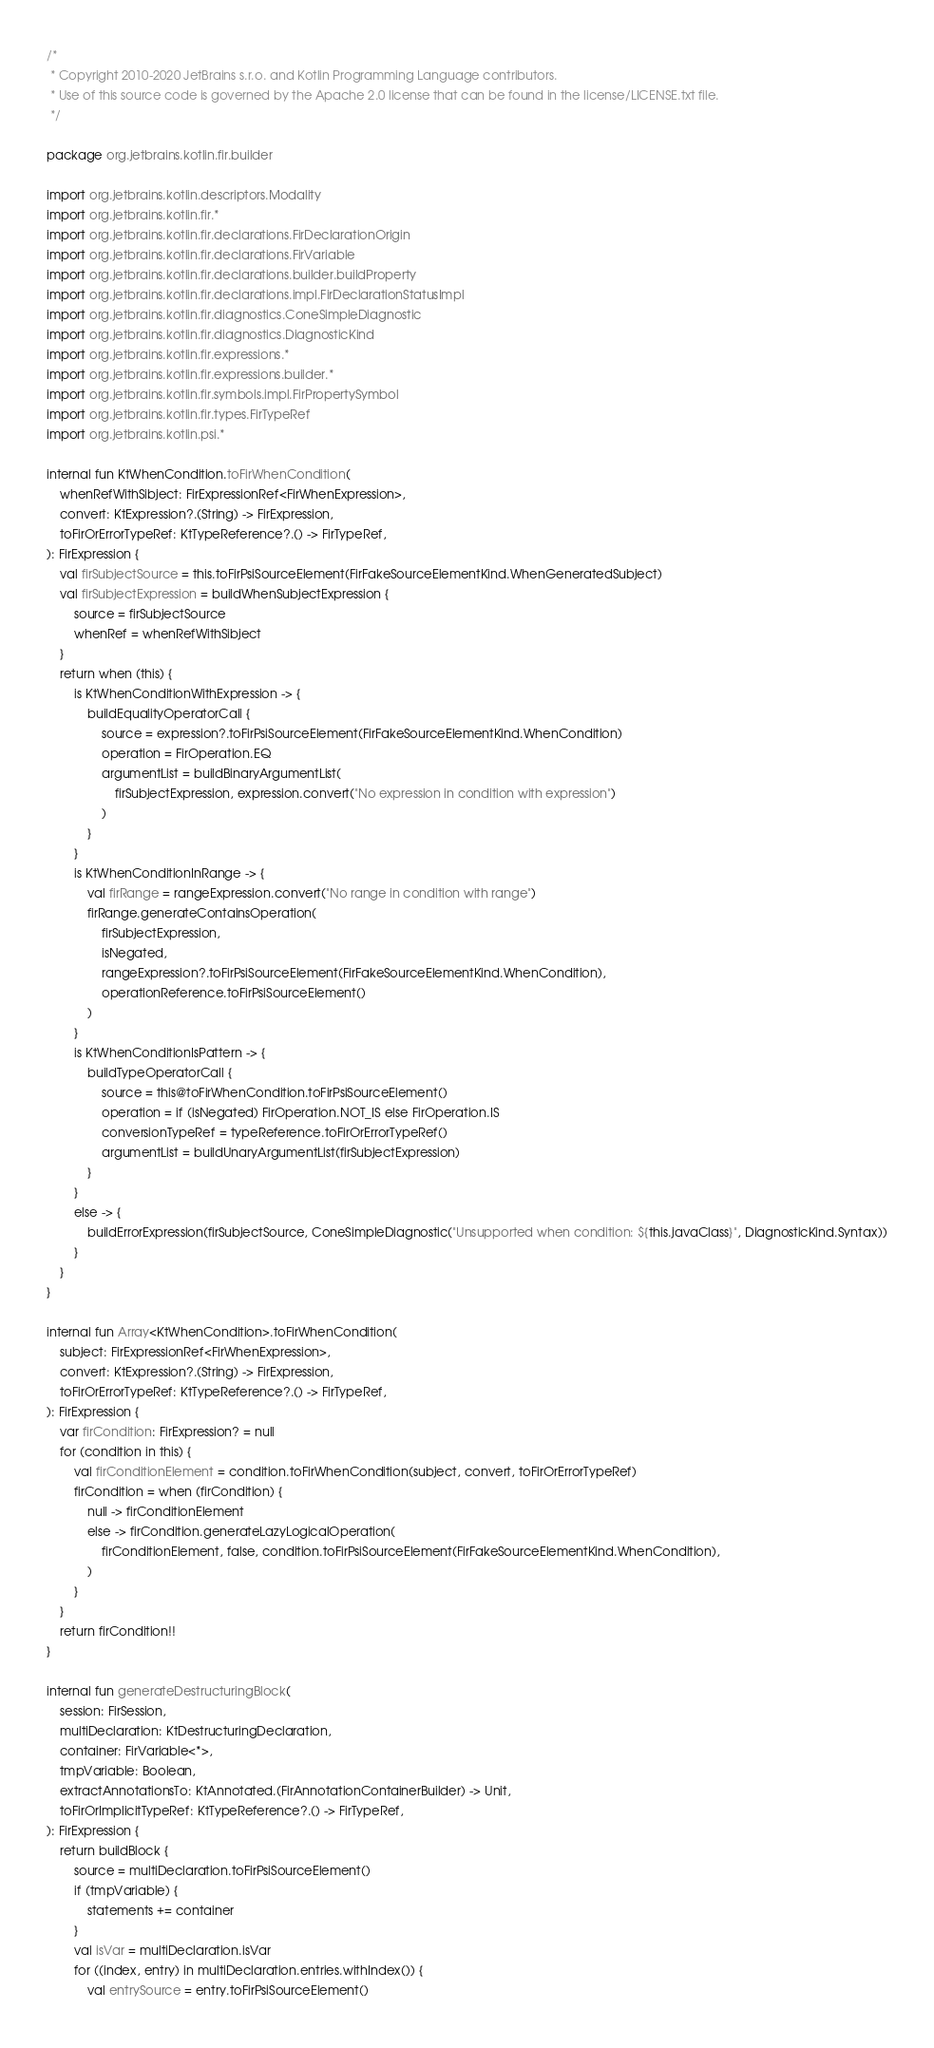Convert code to text. <code><loc_0><loc_0><loc_500><loc_500><_Kotlin_>/*
 * Copyright 2010-2020 JetBrains s.r.o. and Kotlin Programming Language contributors.
 * Use of this source code is governed by the Apache 2.0 license that can be found in the license/LICENSE.txt file.
 */

package org.jetbrains.kotlin.fir.builder

import org.jetbrains.kotlin.descriptors.Modality
import org.jetbrains.kotlin.fir.*
import org.jetbrains.kotlin.fir.declarations.FirDeclarationOrigin
import org.jetbrains.kotlin.fir.declarations.FirVariable
import org.jetbrains.kotlin.fir.declarations.builder.buildProperty
import org.jetbrains.kotlin.fir.declarations.impl.FirDeclarationStatusImpl
import org.jetbrains.kotlin.fir.diagnostics.ConeSimpleDiagnostic
import org.jetbrains.kotlin.fir.diagnostics.DiagnosticKind
import org.jetbrains.kotlin.fir.expressions.*
import org.jetbrains.kotlin.fir.expressions.builder.*
import org.jetbrains.kotlin.fir.symbols.impl.FirPropertySymbol
import org.jetbrains.kotlin.fir.types.FirTypeRef
import org.jetbrains.kotlin.psi.*

internal fun KtWhenCondition.toFirWhenCondition(
    whenRefWithSibject: FirExpressionRef<FirWhenExpression>,
    convert: KtExpression?.(String) -> FirExpression,
    toFirOrErrorTypeRef: KtTypeReference?.() -> FirTypeRef,
): FirExpression {
    val firSubjectSource = this.toFirPsiSourceElement(FirFakeSourceElementKind.WhenGeneratedSubject)
    val firSubjectExpression = buildWhenSubjectExpression {
        source = firSubjectSource
        whenRef = whenRefWithSibject
    }
    return when (this) {
        is KtWhenConditionWithExpression -> {
            buildEqualityOperatorCall {
                source = expression?.toFirPsiSourceElement(FirFakeSourceElementKind.WhenCondition)
                operation = FirOperation.EQ
                argumentList = buildBinaryArgumentList(
                    firSubjectExpression, expression.convert("No expression in condition with expression")
                )
            }
        }
        is KtWhenConditionInRange -> {
            val firRange = rangeExpression.convert("No range in condition with range")
            firRange.generateContainsOperation(
                firSubjectExpression,
                isNegated,
                rangeExpression?.toFirPsiSourceElement(FirFakeSourceElementKind.WhenCondition),
                operationReference.toFirPsiSourceElement()
            )
        }
        is KtWhenConditionIsPattern -> {
            buildTypeOperatorCall {
                source = this@toFirWhenCondition.toFirPsiSourceElement()
                operation = if (isNegated) FirOperation.NOT_IS else FirOperation.IS
                conversionTypeRef = typeReference.toFirOrErrorTypeRef()
                argumentList = buildUnaryArgumentList(firSubjectExpression)
            }
        }
        else -> {
            buildErrorExpression(firSubjectSource, ConeSimpleDiagnostic("Unsupported when condition: ${this.javaClass}", DiagnosticKind.Syntax))
        }
    }
}

internal fun Array<KtWhenCondition>.toFirWhenCondition(
    subject: FirExpressionRef<FirWhenExpression>,
    convert: KtExpression?.(String) -> FirExpression,
    toFirOrErrorTypeRef: KtTypeReference?.() -> FirTypeRef,
): FirExpression {
    var firCondition: FirExpression? = null
    for (condition in this) {
        val firConditionElement = condition.toFirWhenCondition(subject, convert, toFirOrErrorTypeRef)
        firCondition = when (firCondition) {
            null -> firConditionElement
            else -> firCondition.generateLazyLogicalOperation(
                firConditionElement, false, condition.toFirPsiSourceElement(FirFakeSourceElementKind.WhenCondition),
            )
        }
    }
    return firCondition!!
}

internal fun generateDestructuringBlock(
    session: FirSession,
    multiDeclaration: KtDestructuringDeclaration,
    container: FirVariable<*>,
    tmpVariable: Boolean,
    extractAnnotationsTo: KtAnnotated.(FirAnnotationContainerBuilder) -> Unit,
    toFirOrImplicitTypeRef: KtTypeReference?.() -> FirTypeRef,
): FirExpression {
    return buildBlock {
        source = multiDeclaration.toFirPsiSourceElement()
        if (tmpVariable) {
            statements += container
        }
        val isVar = multiDeclaration.isVar
        for ((index, entry) in multiDeclaration.entries.withIndex()) {
            val entrySource = entry.toFirPsiSourceElement()</code> 